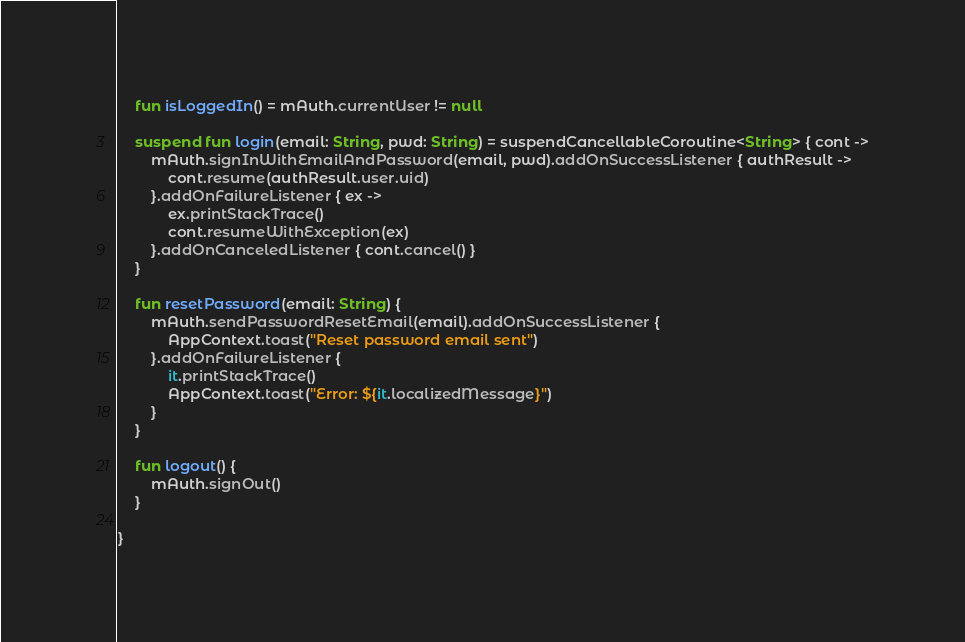<code> <loc_0><loc_0><loc_500><loc_500><_Kotlin_>	fun isLoggedIn() = mAuth.currentUser != null
	
	suspend fun login(email: String, pwd: String) = suspendCancellableCoroutine<String> { cont ->
		mAuth.signInWithEmailAndPassword(email, pwd).addOnSuccessListener { authResult ->
			cont.resume(authResult.user.uid)
		}.addOnFailureListener { ex ->
			ex.printStackTrace()
			cont.resumeWithException(ex)
		}.addOnCanceledListener { cont.cancel() }
	}
	
	fun resetPassword(email: String) {
		mAuth.sendPasswordResetEmail(email).addOnSuccessListener {
			AppContext.toast("Reset password email sent")
		}.addOnFailureListener {
			it.printStackTrace()
			AppContext.toast("Error: ${it.localizedMessage}")
		}
	}
	
	fun logout() {
		mAuth.signOut()
	}
	
}</code> 